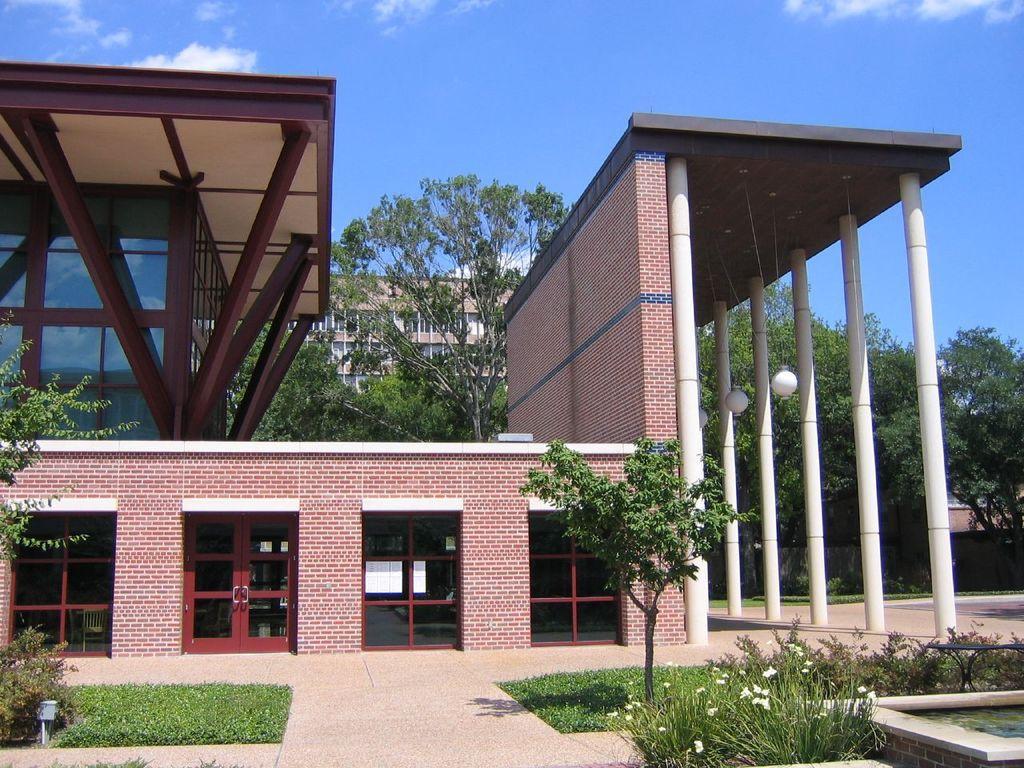In one or two sentences, can you explain what this image depicts? In this picture we can see some grass on the path. There are a few plants and trees on the path. We can see a building. There is a door and door handle on this building. We can see some trees and another building in the background. There is water on the right side. 